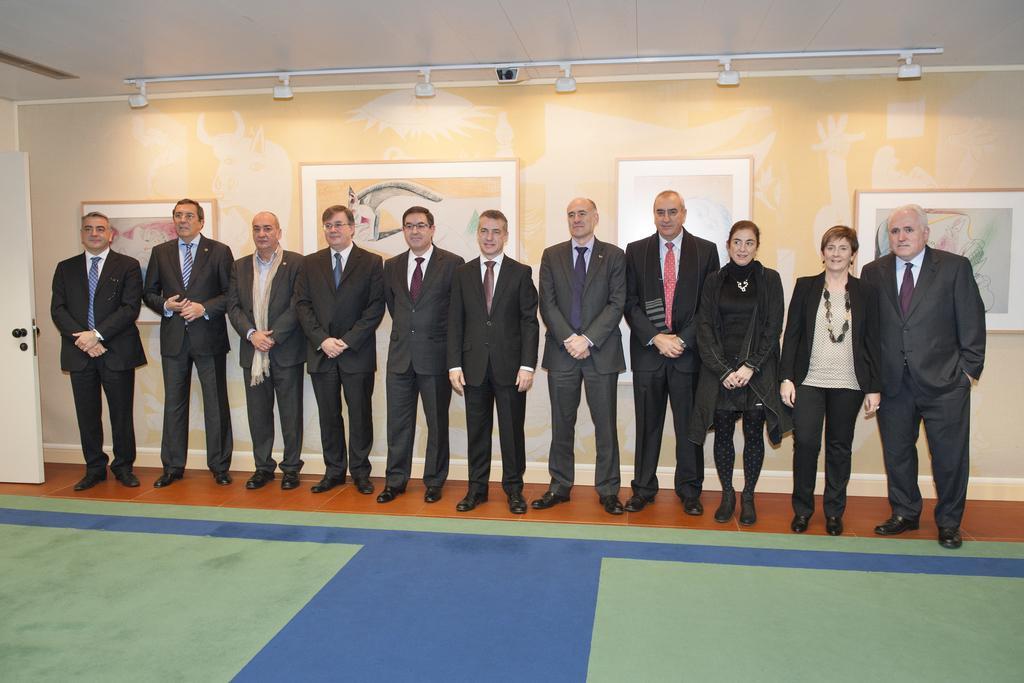In one or two sentences, can you explain what this image depicts? In this image few persons and two women are standing on the floor. behind them there is a wall having few picture frames attached to the wall. Few lights are attached to the roof. Persons are wearing suits and ties. Women are wearing black jackets. Left side there is a door. 